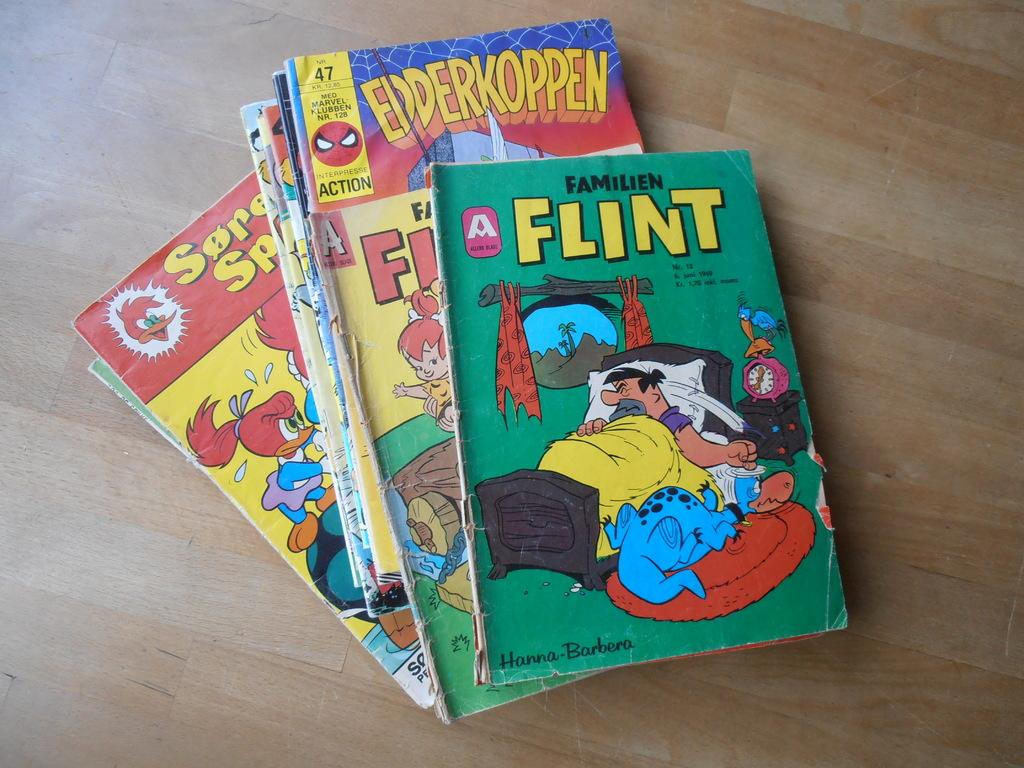<image>
Provide a brief description of the given image. A Flint comic book on top of other comics. 